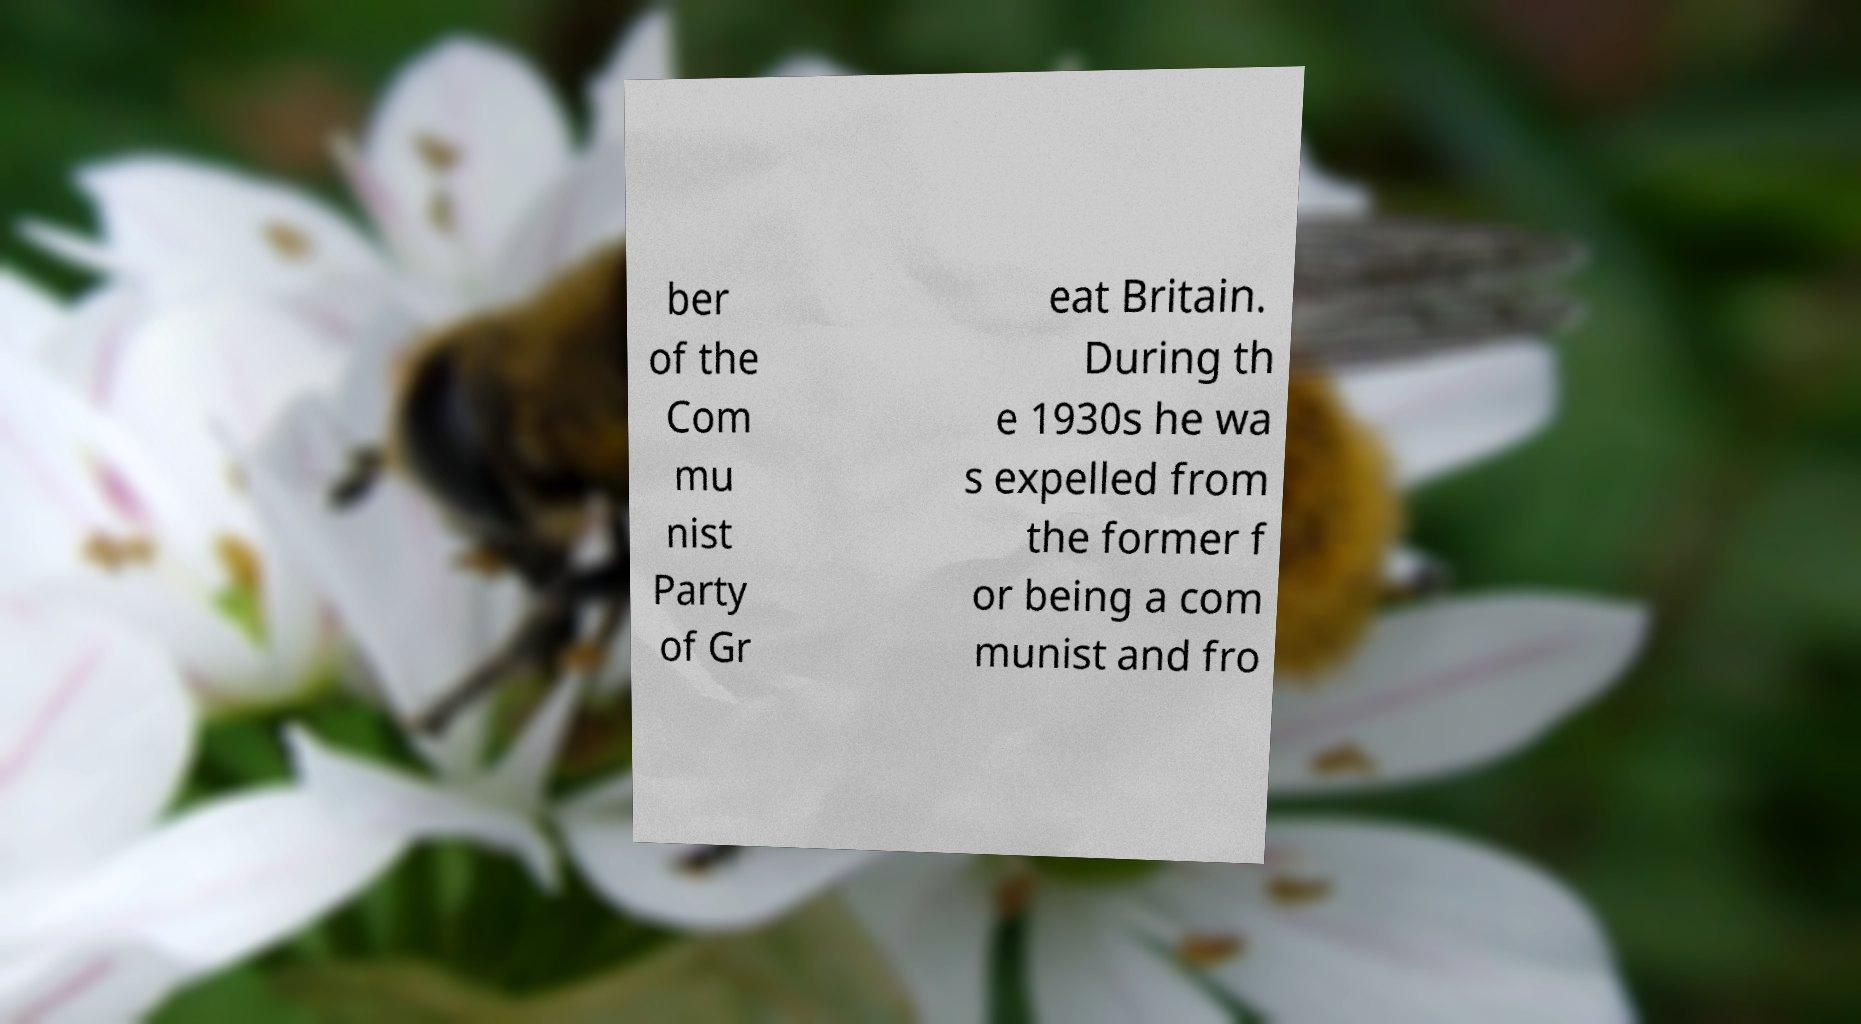I need the written content from this picture converted into text. Can you do that? ber of the Com mu nist Party of Gr eat Britain. During th e 1930s he wa s expelled from the former f or being a com munist and fro 